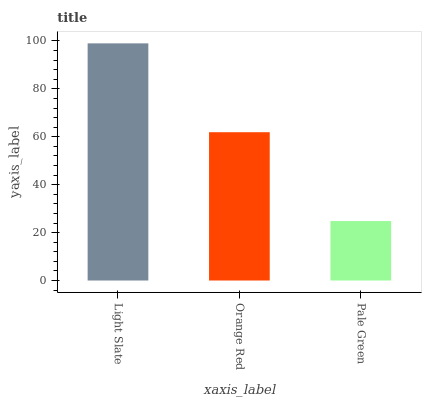Is Pale Green the minimum?
Answer yes or no. Yes. Is Light Slate the maximum?
Answer yes or no. Yes. Is Orange Red the minimum?
Answer yes or no. No. Is Orange Red the maximum?
Answer yes or no. No. Is Light Slate greater than Orange Red?
Answer yes or no. Yes. Is Orange Red less than Light Slate?
Answer yes or no. Yes. Is Orange Red greater than Light Slate?
Answer yes or no. No. Is Light Slate less than Orange Red?
Answer yes or no. No. Is Orange Red the high median?
Answer yes or no. Yes. Is Orange Red the low median?
Answer yes or no. Yes. Is Pale Green the high median?
Answer yes or no. No. Is Pale Green the low median?
Answer yes or no. No. 